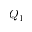<formula> <loc_0><loc_0><loc_500><loc_500>Q _ { 1 }</formula> 